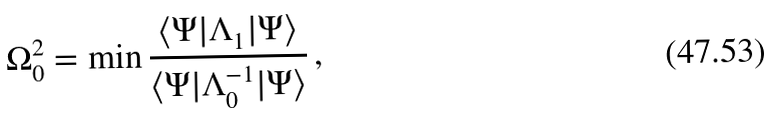<formula> <loc_0><loc_0><loc_500><loc_500>\Omega _ { 0 } ^ { 2 } = \min \frac { \langle \Psi | \Lambda _ { 1 } | \Psi \rangle } { \langle \Psi | \Lambda _ { 0 } ^ { - 1 } | \Psi \rangle } \, ,</formula> 